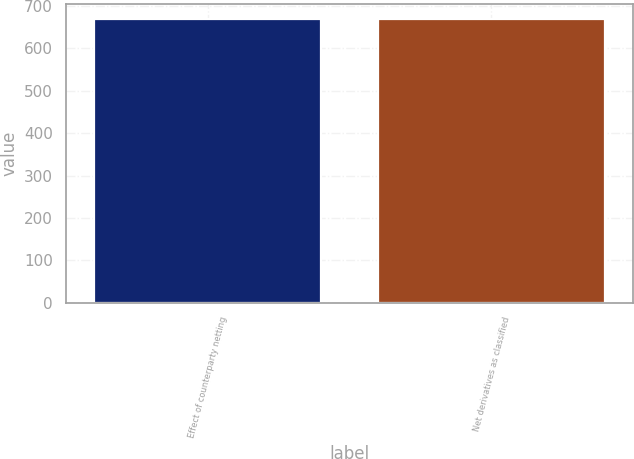Convert chart to OTSL. <chart><loc_0><loc_0><loc_500><loc_500><bar_chart><fcel>Effect of counterparty netting<fcel>Net derivatives as classified<nl><fcel>670<fcel>670.1<nl></chart> 